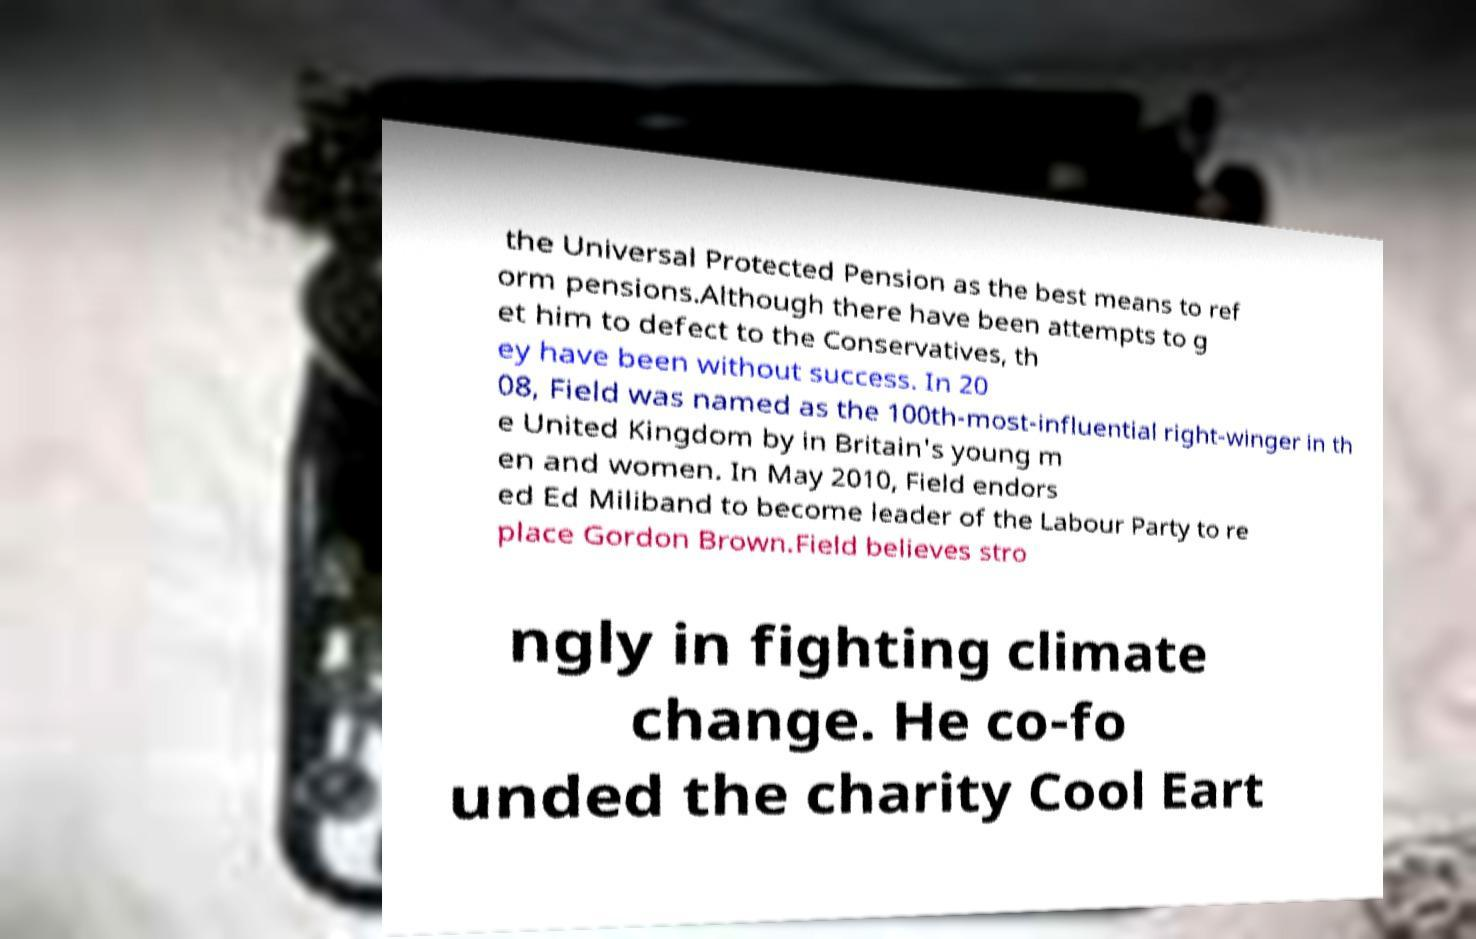Please read and relay the text visible in this image. What does it say? the Universal Protected Pension as the best means to ref orm pensions.Although there have been attempts to g et him to defect to the Conservatives, th ey have been without success. In 20 08, Field was named as the 100th-most-influential right-winger in th e United Kingdom by in Britain's young m en and women. In May 2010, Field endors ed Ed Miliband to become leader of the Labour Party to re place Gordon Brown.Field believes stro ngly in fighting climate change. He co-fo unded the charity Cool Eart 